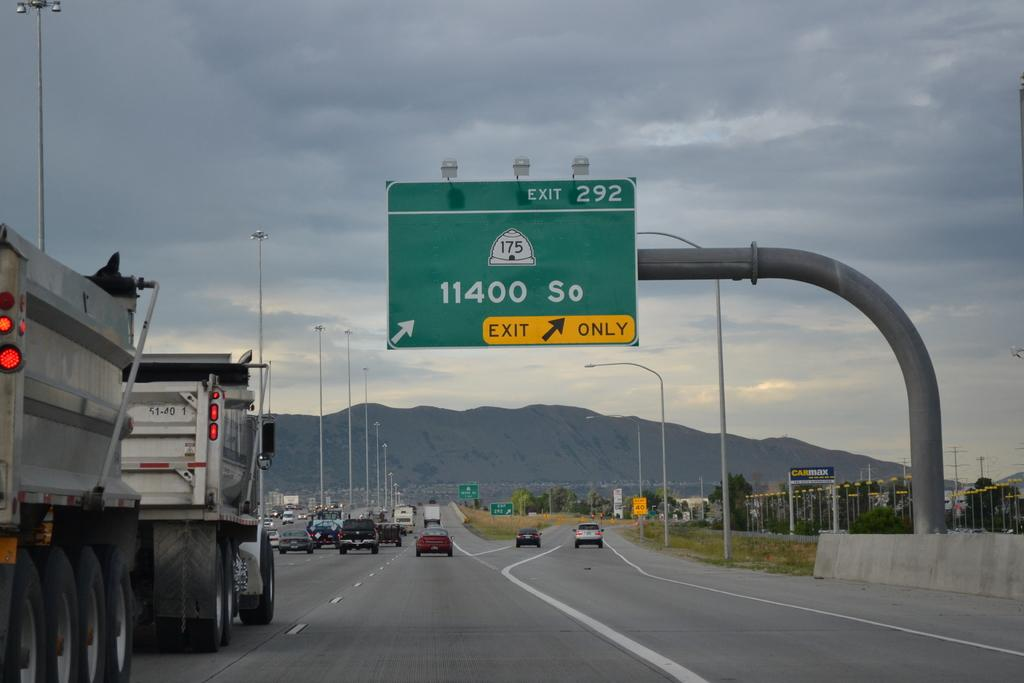<image>
Create a compact narrative representing the image presented. A highway with a sign with 11400 so exit sign. 